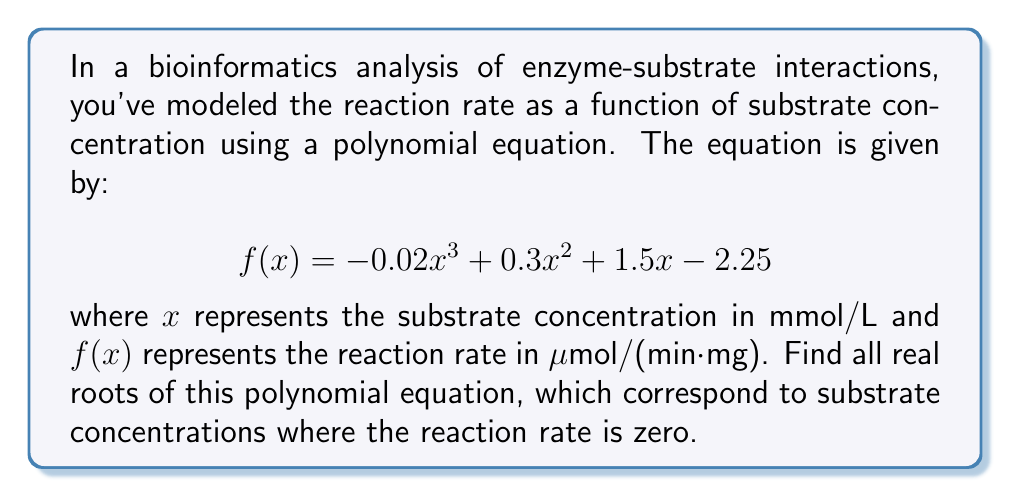Give your solution to this math problem. To find the roots of this polynomial equation, we need to solve $f(x) = 0$. Let's approach this step-by-step:

1) First, we set the equation equal to zero:
   $$-0.02x^3 + 0.3x^2 + 1.5x - 2.25 = 0$$

2) We can factor out the greatest common factor:
   $$0.02(-x^3 + 15x^2 + 75x - 112.5) = 0$$

3) Dividing both sides by 0.02:
   $$-x^3 + 15x^2 + 75x - 112.5 = 0$$

4) This cubic equation doesn't have any obvious rational roots, so we need to use the cubic formula or a numerical method. Using a computer algebra system or graphing calculator, we find that this equation has three real roots.

5) The three roots are approximately:
   $x_1 \approx 1.5$
   $x_2 \approx 5.0$
   $x_3 \approx 8.5$

6) These roots represent the substrate concentrations (in mmol/L) at which the reaction rate is zero.

7) We can verify these roots by substituting them back into the original equation:

   For $x = 1.5$:
   $f(1.5) = -0.02(1.5)^3 + 0.3(1.5)^2 + 1.5(1.5) - 2.25 \approx 0$

   For $x = 5.0$:
   $f(5.0) = -0.02(5.0)^3 + 0.3(5.0)^2 + 1.5(5.0) - 2.25 \approx 0$

   For $x = 8.5$:
   $f(8.5) = -0.02(8.5)^3 + 0.3(8.5)^2 + 1.5(8.5) - 2.25 \approx 0$
Answer: $x \approx 1.5, 5.0, 8.5$ mmol/L 